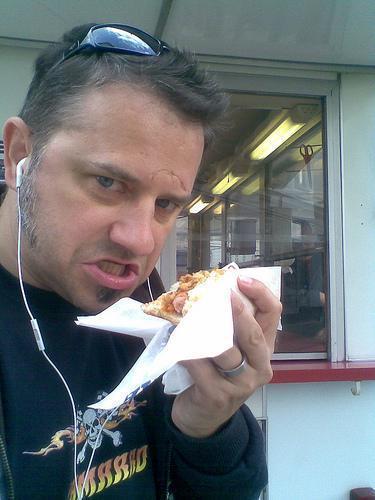How many people are pictured?
Give a very brief answer. 1. How many fingers have rings on them?
Give a very brief answer. 1. 